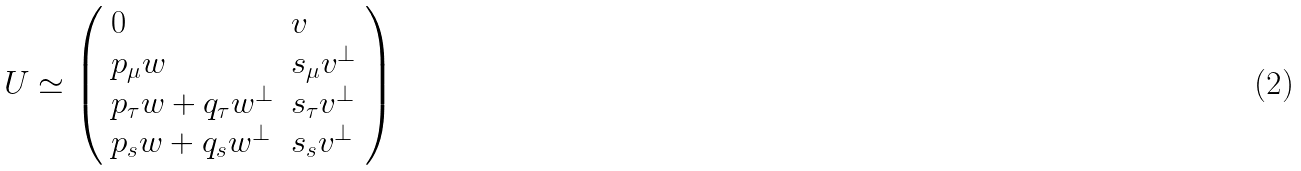Convert formula to latex. <formula><loc_0><loc_0><loc_500><loc_500>U \simeq \left ( \begin{array} { l l } 0 & v \\ p _ { \mu } w & s _ { \mu } v ^ { \bot } \\ p _ { \tau } w + q _ { \tau } w ^ { \bot } & s _ { \tau } v ^ { \bot } \\ p _ { s } w + q _ { s } w ^ { \bot } & s _ { s } v ^ { \bot } \end{array} \right )</formula> 